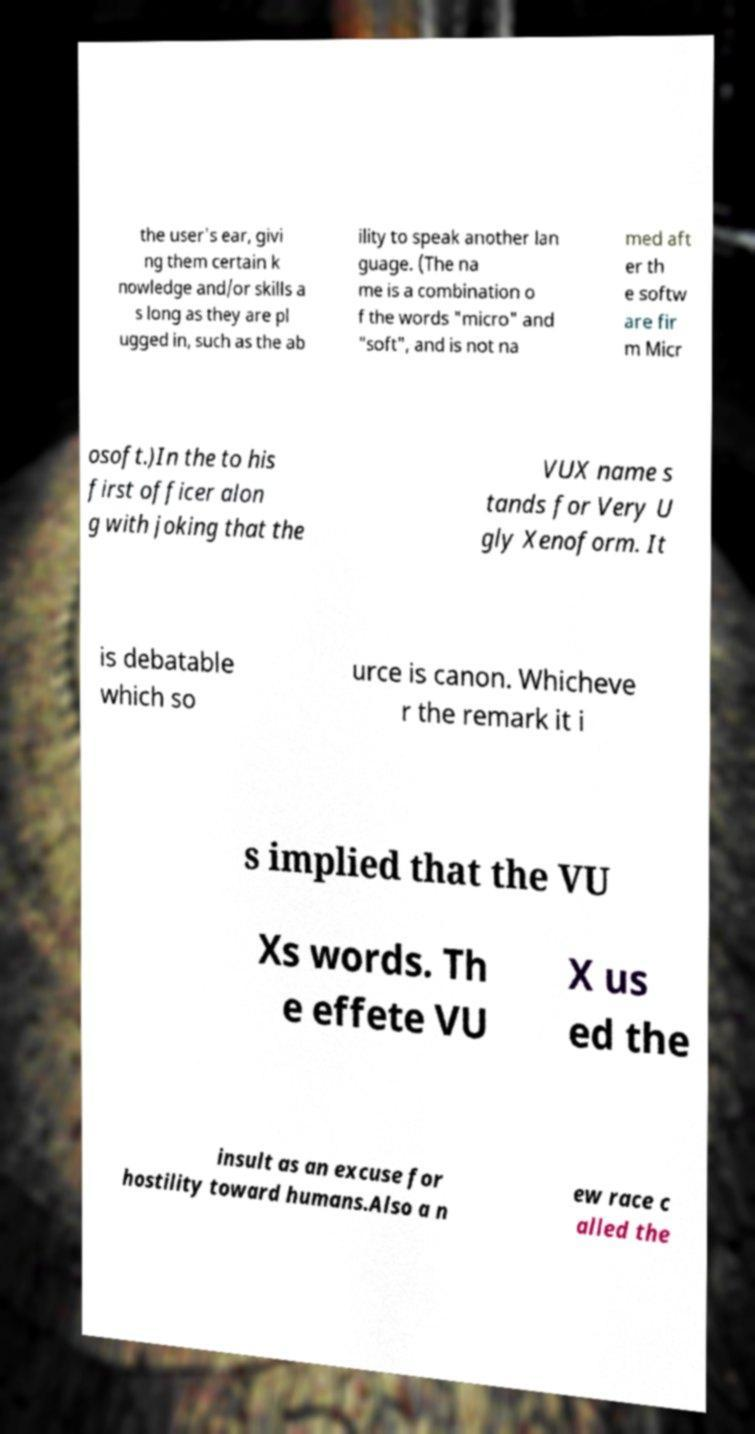Could you assist in decoding the text presented in this image and type it out clearly? the user's ear, givi ng them certain k nowledge and/or skills a s long as they are pl ugged in, such as the ab ility to speak another lan guage. (The na me is a combination o f the words "micro" and "soft", and is not na med aft er th e softw are fir m Micr osoft.)In the to his first officer alon g with joking that the VUX name s tands for Very U gly Xenoform. It is debatable which so urce is canon. Whicheve r the remark it i s implied that the VU Xs words. Th e effete VU X us ed the insult as an excuse for hostility toward humans.Also a n ew race c alled the 